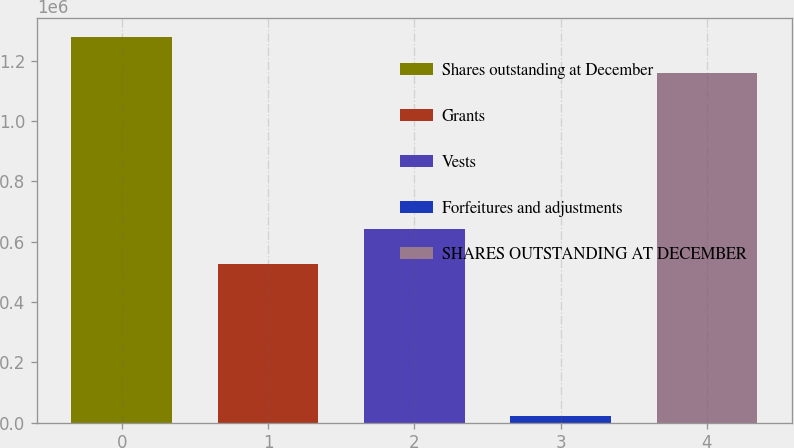<chart> <loc_0><loc_0><loc_500><loc_500><bar_chart><fcel>Shares outstanding at December<fcel>Grants<fcel>Vests<fcel>Forfeitures and adjustments<fcel>SHARES OUTSTANDING AT DECEMBER<nl><fcel>1.27844e+06<fcel>525124<fcel>643470<fcel>22555<fcel>1.16009e+06<nl></chart> 